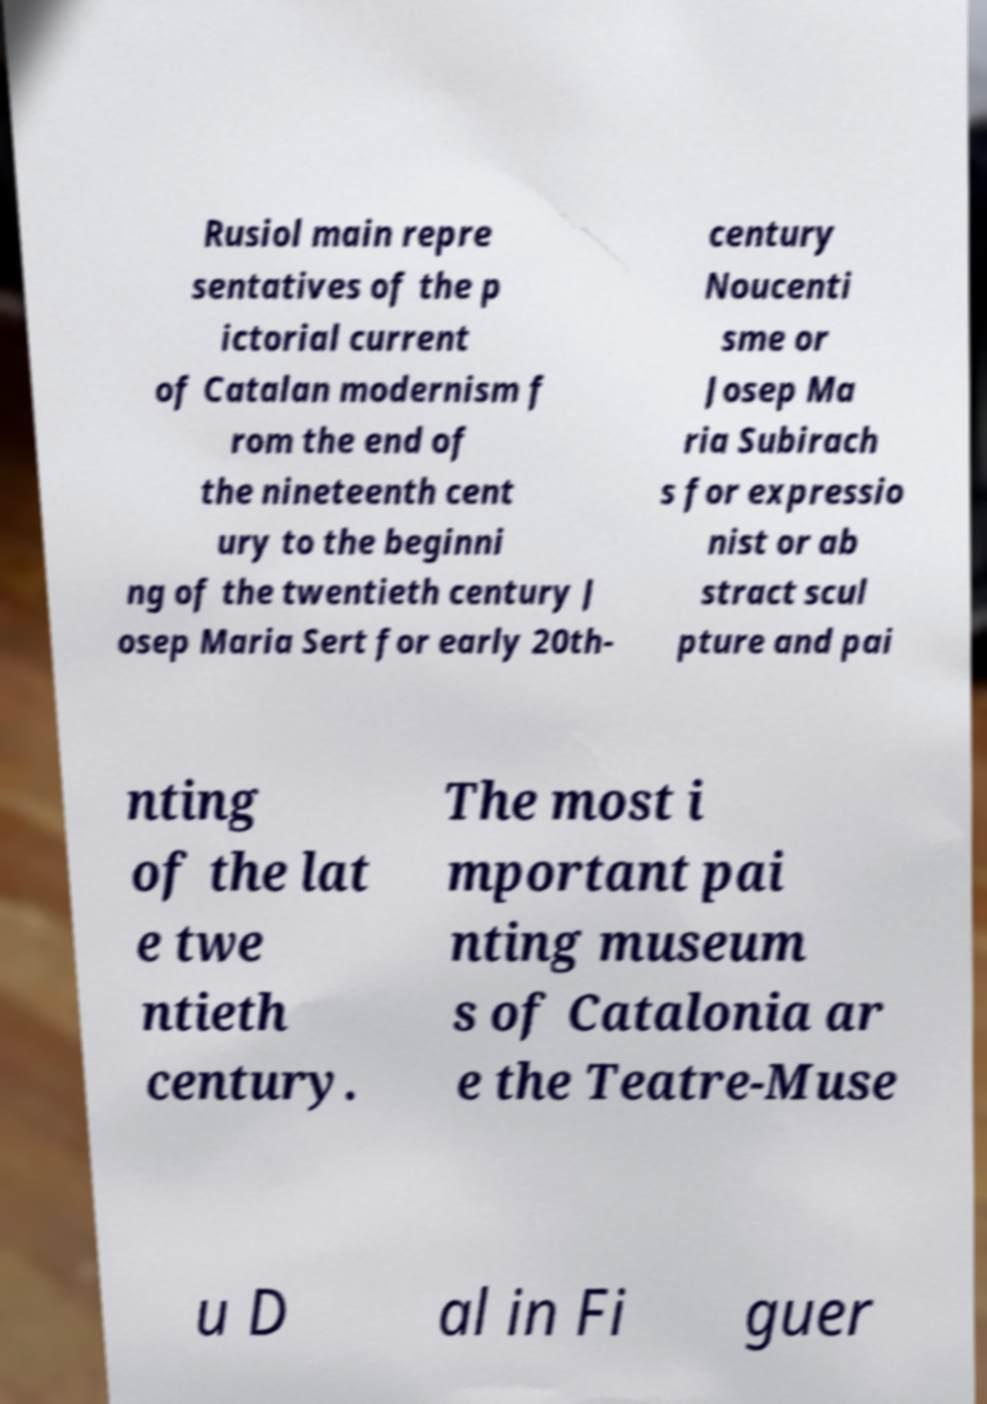Can you accurately transcribe the text from the provided image for me? Rusiol main repre sentatives of the p ictorial current of Catalan modernism f rom the end of the nineteenth cent ury to the beginni ng of the twentieth century J osep Maria Sert for early 20th- century Noucenti sme or Josep Ma ria Subirach s for expressio nist or ab stract scul pture and pai nting of the lat e twe ntieth century. The most i mportant pai nting museum s of Catalonia ar e the Teatre-Muse u D al in Fi guer 